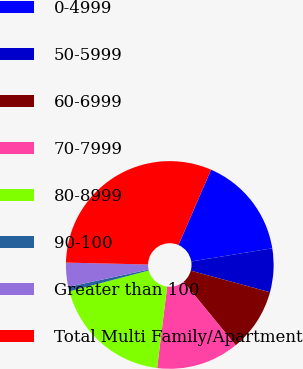Convert chart to OTSL. <chart><loc_0><loc_0><loc_500><loc_500><pie_chart><fcel>0-4999<fcel>50-5999<fcel>60-6999<fcel>70-7999<fcel>80-8999<fcel>90-100<fcel>Greater than 100<fcel>Total Multi Family/Apartment<nl><fcel>15.93%<fcel>6.79%<fcel>9.84%<fcel>12.88%<fcel>18.97%<fcel>0.7%<fcel>3.75%<fcel>31.15%<nl></chart> 